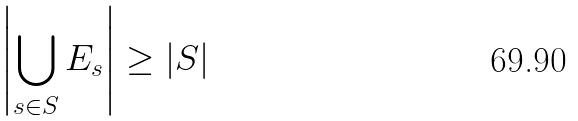Convert formula to latex. <formula><loc_0><loc_0><loc_500><loc_500>\left | \bigcup _ { s \in S } E _ { s } \right | \geq \left | S \right |</formula> 